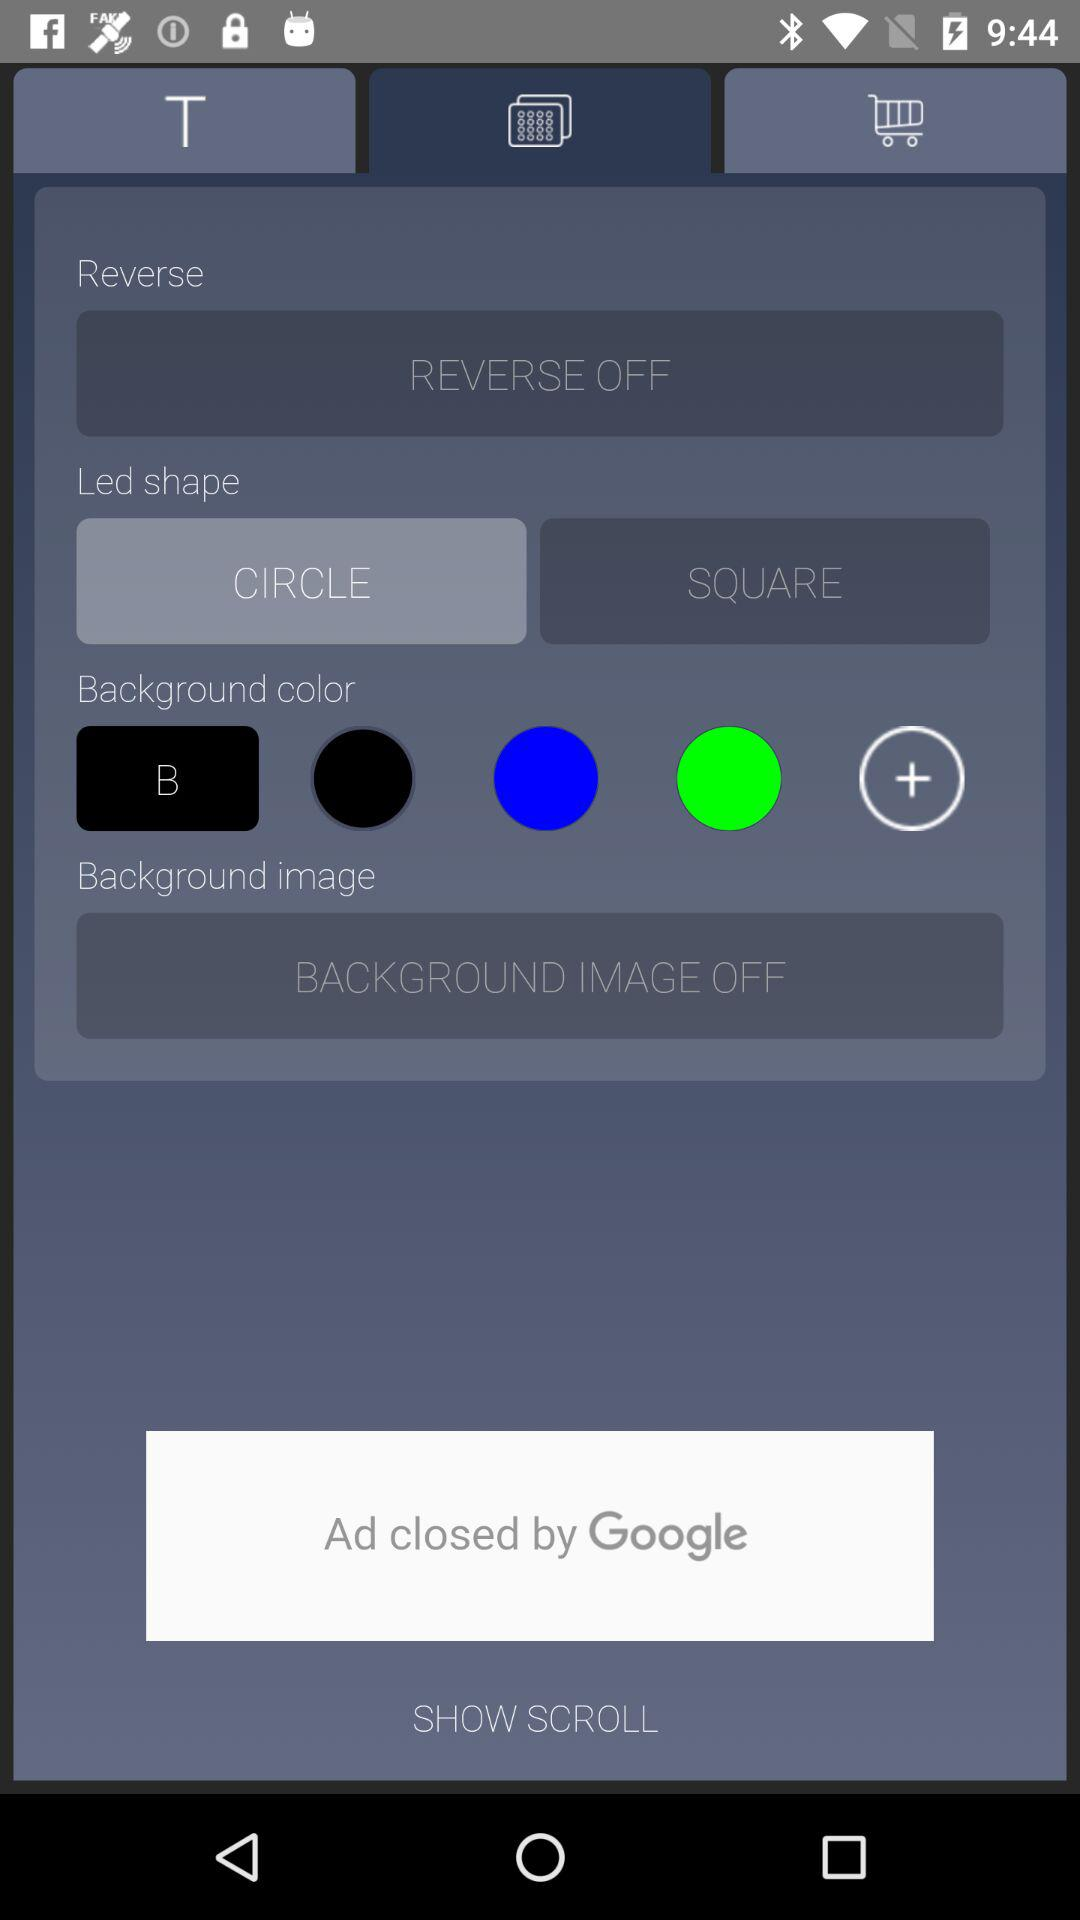What's the status of "Reverse"? The status of "Reverse" is "off". 